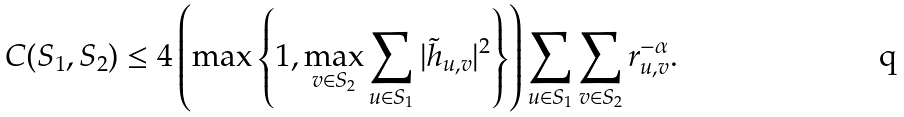<formula> <loc_0><loc_0><loc_500><loc_500>C ( S _ { 1 } , S _ { 2 } ) \leq 4 \left ( \max \left \{ 1 , \max _ { v \in S _ { 2 } } \sum _ { u \in S _ { 1 } } | \tilde { h } _ { u , v } | ^ { 2 } \right \} \right ) \sum _ { u \in S _ { 1 } } \sum _ { v \in S _ { 2 } } r _ { u , v } ^ { - \alpha } .</formula> 